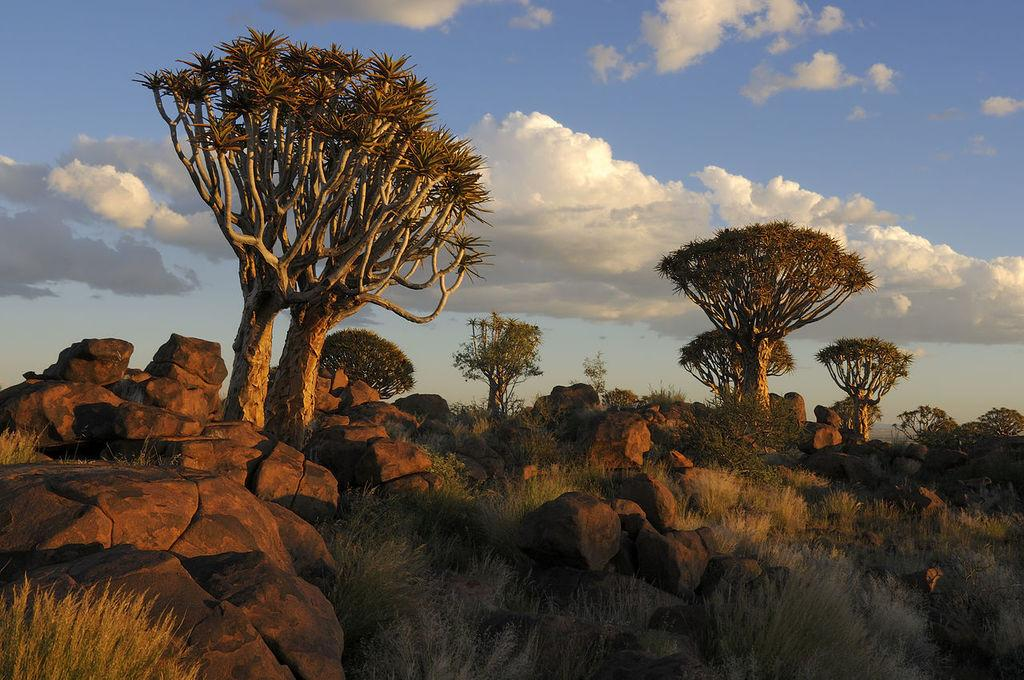What type of natural features can be seen in the image? There are rocks, grassland, and trees in the image. What is visible at the top of the image? The sky is visible at the top of the image. What title is written on the rocks in the image? There is no title written on the rocks in the image; the rocks are natural features without any text. 